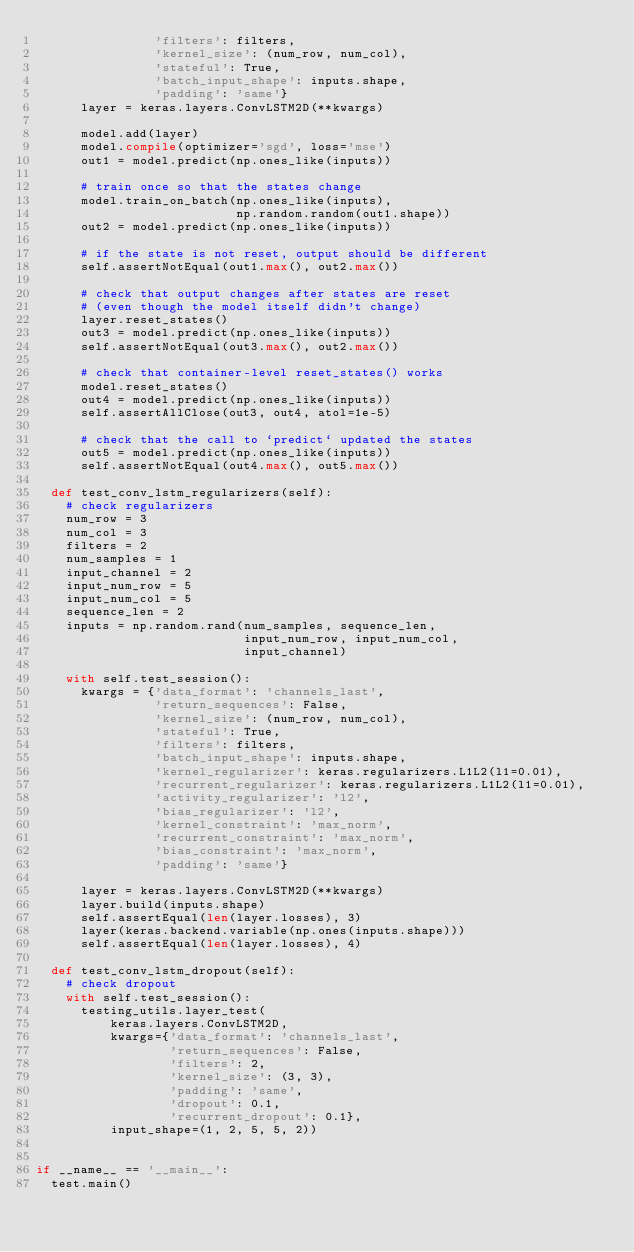<code> <loc_0><loc_0><loc_500><loc_500><_Python_>                'filters': filters,
                'kernel_size': (num_row, num_col),
                'stateful': True,
                'batch_input_shape': inputs.shape,
                'padding': 'same'}
      layer = keras.layers.ConvLSTM2D(**kwargs)

      model.add(layer)
      model.compile(optimizer='sgd', loss='mse')
      out1 = model.predict(np.ones_like(inputs))

      # train once so that the states change
      model.train_on_batch(np.ones_like(inputs),
                           np.random.random(out1.shape))
      out2 = model.predict(np.ones_like(inputs))

      # if the state is not reset, output should be different
      self.assertNotEqual(out1.max(), out2.max())

      # check that output changes after states are reset
      # (even though the model itself didn't change)
      layer.reset_states()
      out3 = model.predict(np.ones_like(inputs))
      self.assertNotEqual(out3.max(), out2.max())

      # check that container-level reset_states() works
      model.reset_states()
      out4 = model.predict(np.ones_like(inputs))
      self.assertAllClose(out3, out4, atol=1e-5)

      # check that the call to `predict` updated the states
      out5 = model.predict(np.ones_like(inputs))
      self.assertNotEqual(out4.max(), out5.max())

  def test_conv_lstm_regularizers(self):
    # check regularizers
    num_row = 3
    num_col = 3
    filters = 2
    num_samples = 1
    input_channel = 2
    input_num_row = 5
    input_num_col = 5
    sequence_len = 2
    inputs = np.random.rand(num_samples, sequence_len,
                            input_num_row, input_num_col,
                            input_channel)

    with self.test_session():
      kwargs = {'data_format': 'channels_last',
                'return_sequences': False,
                'kernel_size': (num_row, num_col),
                'stateful': True,
                'filters': filters,
                'batch_input_shape': inputs.shape,
                'kernel_regularizer': keras.regularizers.L1L2(l1=0.01),
                'recurrent_regularizer': keras.regularizers.L1L2(l1=0.01),
                'activity_regularizer': 'l2',
                'bias_regularizer': 'l2',
                'kernel_constraint': 'max_norm',
                'recurrent_constraint': 'max_norm',
                'bias_constraint': 'max_norm',
                'padding': 'same'}

      layer = keras.layers.ConvLSTM2D(**kwargs)
      layer.build(inputs.shape)
      self.assertEqual(len(layer.losses), 3)
      layer(keras.backend.variable(np.ones(inputs.shape)))
      self.assertEqual(len(layer.losses), 4)

  def test_conv_lstm_dropout(self):
    # check dropout
    with self.test_session():
      testing_utils.layer_test(
          keras.layers.ConvLSTM2D,
          kwargs={'data_format': 'channels_last',
                  'return_sequences': False,
                  'filters': 2,
                  'kernel_size': (3, 3),
                  'padding': 'same',
                  'dropout': 0.1,
                  'recurrent_dropout': 0.1},
          input_shape=(1, 2, 5, 5, 2))


if __name__ == '__main__':
  test.main()
</code> 